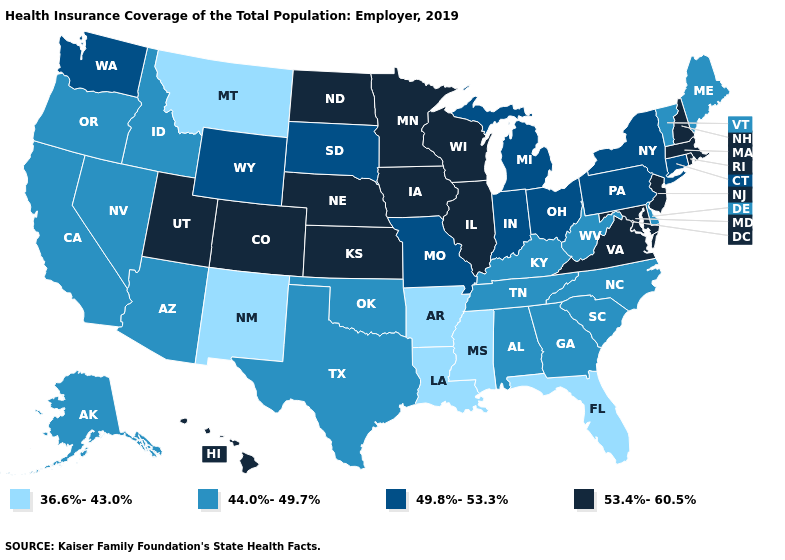Does the map have missing data?
Give a very brief answer. No. Is the legend a continuous bar?
Give a very brief answer. No. What is the value of Hawaii?
Short answer required. 53.4%-60.5%. What is the value of Alaska?
Keep it brief. 44.0%-49.7%. Does California have the same value as Kentucky?
Quick response, please. Yes. Does the first symbol in the legend represent the smallest category?
Give a very brief answer. Yes. What is the value of Maryland?
Keep it brief. 53.4%-60.5%. What is the value of New Jersey?
Give a very brief answer. 53.4%-60.5%. What is the lowest value in the USA?
Be succinct. 36.6%-43.0%. What is the value of Florida?
Be succinct. 36.6%-43.0%. Name the states that have a value in the range 36.6%-43.0%?
Give a very brief answer. Arkansas, Florida, Louisiana, Mississippi, Montana, New Mexico. Does New York have a higher value than Maryland?
Short answer required. No. What is the value of North Dakota?
Give a very brief answer. 53.4%-60.5%. Which states have the lowest value in the USA?
Concise answer only. Arkansas, Florida, Louisiana, Mississippi, Montana, New Mexico. Which states have the lowest value in the Northeast?
Be succinct. Maine, Vermont. 